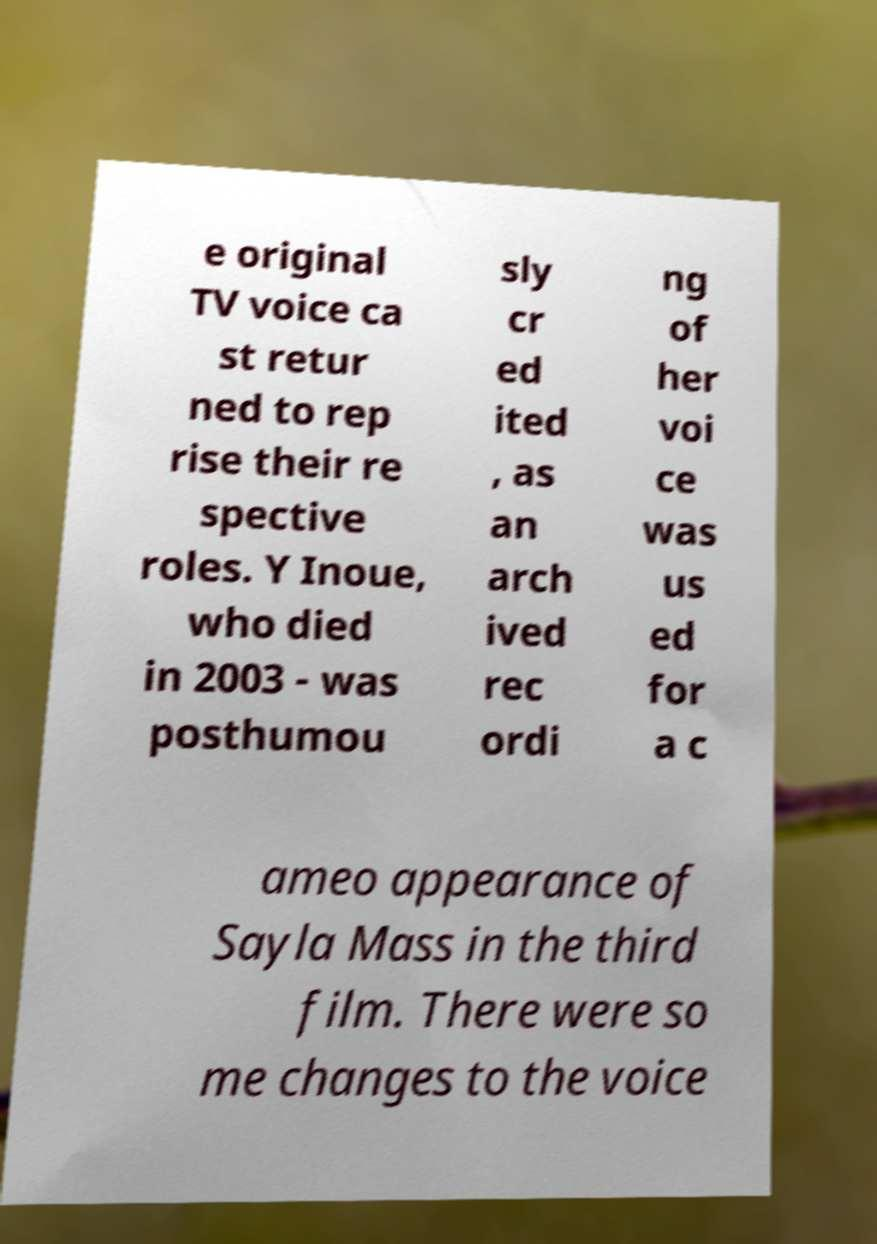What messages or text are displayed in this image? I need them in a readable, typed format. e original TV voice ca st retur ned to rep rise their re spective roles. Y Inoue, who died in 2003 - was posthumou sly cr ed ited , as an arch ived rec ordi ng of her voi ce was us ed for a c ameo appearance of Sayla Mass in the third film. There were so me changes to the voice 